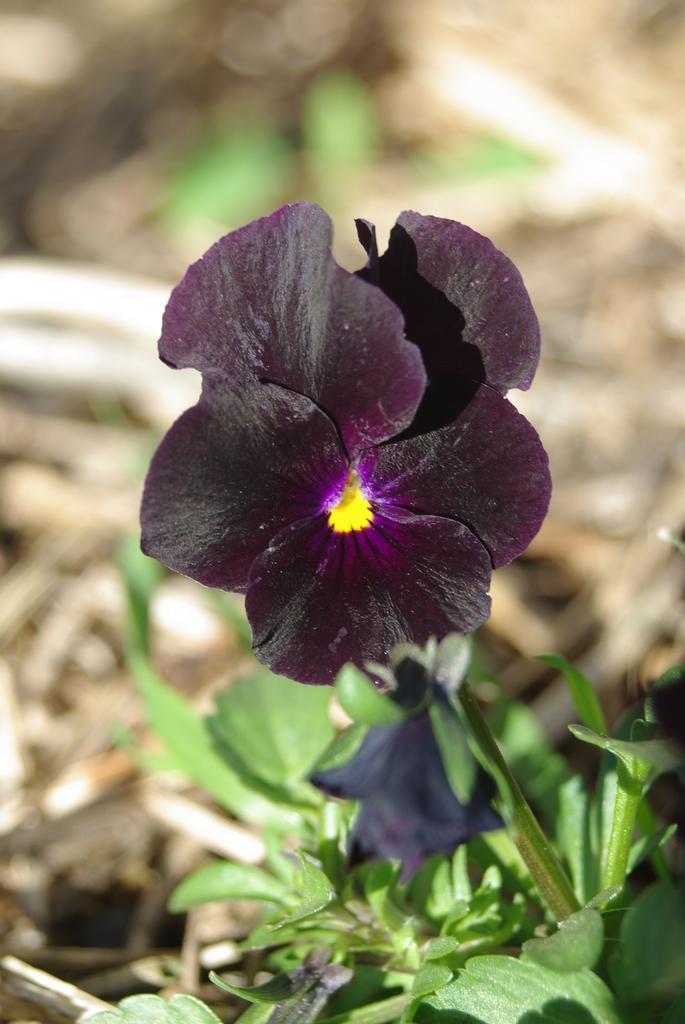What is present in the image? There is a plant in the image. What specific feature can be observed on the plant? The plant has a flower. Can you describe the background of the image? The background behind the flower is blurred. Where is the pin located in the image? There is no pin present in the image. Is the plant in a pot in the image? The provided facts do not mention a pot, so we cannot definitively answer whether the plant is in a pot or not. 